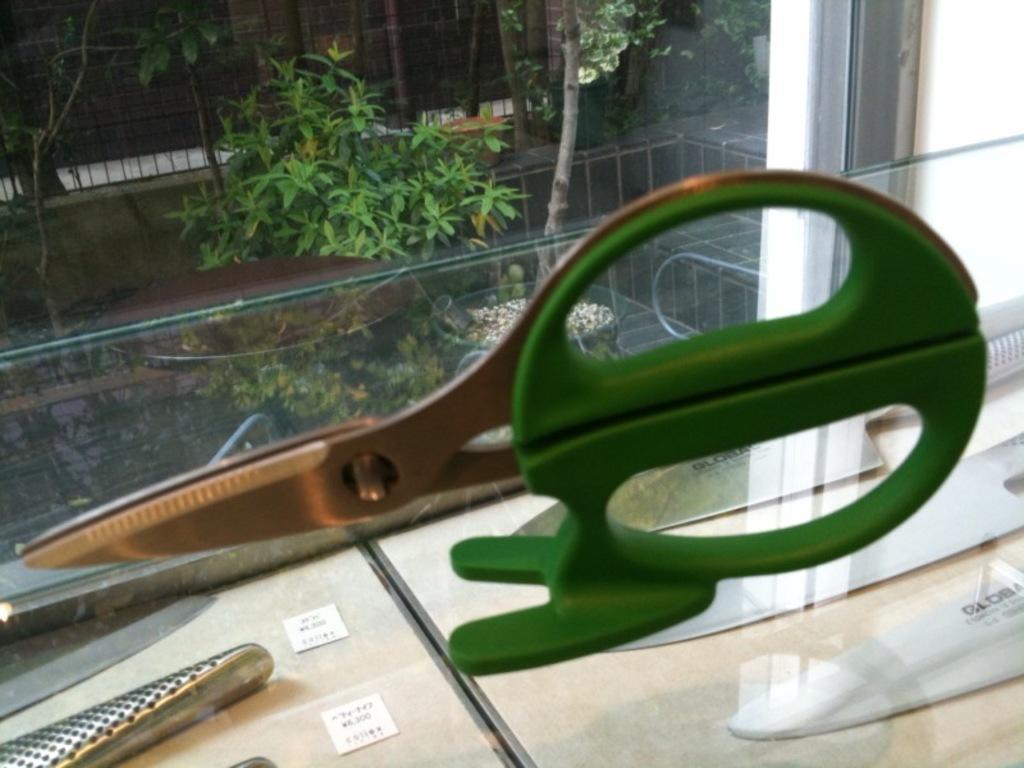Can you describe this image briefly? In this picture I can see scissors on the glass, there are knives and cards on the boards, and in the background there are trees. 